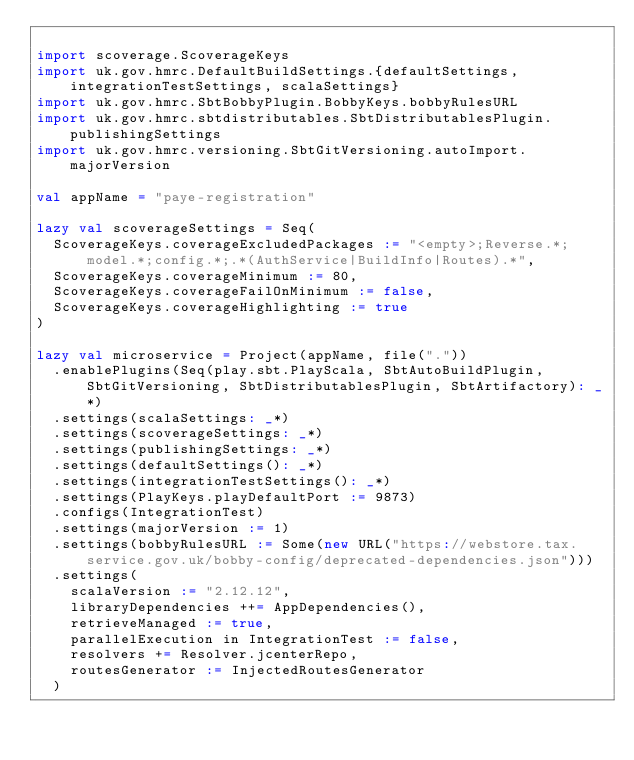<code> <loc_0><loc_0><loc_500><loc_500><_Scala_>
import scoverage.ScoverageKeys
import uk.gov.hmrc.DefaultBuildSettings.{defaultSettings, integrationTestSettings, scalaSettings}
import uk.gov.hmrc.SbtBobbyPlugin.BobbyKeys.bobbyRulesURL
import uk.gov.hmrc.sbtdistributables.SbtDistributablesPlugin.publishingSettings
import uk.gov.hmrc.versioning.SbtGitVersioning.autoImport.majorVersion

val appName = "paye-registration"

lazy val scoverageSettings = Seq(
  ScoverageKeys.coverageExcludedPackages := "<empty>;Reverse.*;model.*;config.*;.*(AuthService|BuildInfo|Routes).*",
  ScoverageKeys.coverageMinimum := 80,
  ScoverageKeys.coverageFailOnMinimum := false,
  ScoverageKeys.coverageHighlighting := true
)

lazy val microservice = Project(appName, file("."))
  .enablePlugins(Seq(play.sbt.PlayScala, SbtAutoBuildPlugin, SbtGitVersioning, SbtDistributablesPlugin, SbtArtifactory): _*)
  .settings(scalaSettings: _*)
  .settings(scoverageSettings: _*)
  .settings(publishingSettings: _*)
  .settings(defaultSettings(): _*)
  .settings(integrationTestSettings(): _*)
  .settings(PlayKeys.playDefaultPort := 9873)
  .configs(IntegrationTest)
  .settings(majorVersion := 1)
  .settings(bobbyRulesURL := Some(new URL("https://webstore.tax.service.gov.uk/bobby-config/deprecated-dependencies.json")))
  .settings(
    scalaVersion := "2.12.12",
    libraryDependencies ++= AppDependencies(),
    retrieveManaged := true,
    parallelExecution in IntegrationTest := false,
    resolvers += Resolver.jcenterRepo,
    routesGenerator := InjectedRoutesGenerator
  )</code> 